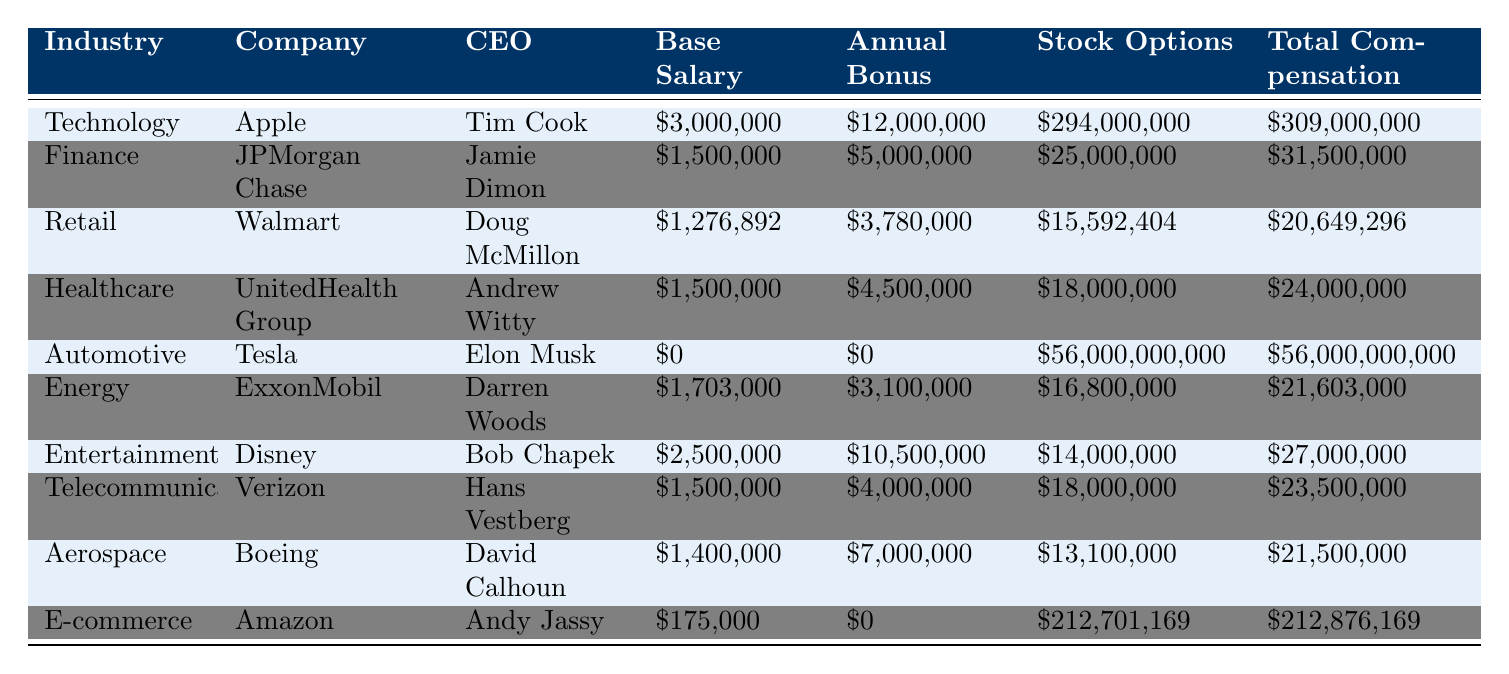What is the total compensation for Elon Musk? According to the table, the total compensation for Elon Musk, who is the CEO of Tesla, is listed as $56,000,000,000.
Answer: $56,000,000,000 Which CEO has the highest annual bonus? Reviewing the table, Tim Cook from Apple has the highest annual bonus of $12,000,000.
Answer: Tim Cook What is the average base salary of the CEOs listed in the table? The base salaries listed are $3,000,000 (Apple), $1,500,000 (JPMorgan Chase), $1,276,892 (Walmart), $1,500,000 (UnitedHealth Group), $0 (Tesla), $1,703,000 (ExxonMobil), $2,500,000 (Disney), $1,500,000 (Verizon), $1,400,000 (Boeing), and $175,000 (Amazon). Summing these gives $12,654,892. Dividing by the total count of CEOs (10) results in an average of $1,265,489.20.
Answer: $1,265,489.20 Is the total compensation for Amazon's CEO higher than that of JPMorgan Chase's CEO? The total compensation for Amazon's CEO, Andy Jassy, is $212,876,169, while for JPMorgan Chase's CEO, Jamie Dimon, it is $31,500,000. Comparing both values, $212,876,169 is greater than $31,500,000.
Answer: Yes What is the difference in total compensation between the highest and lowest paid CEOs? The highest total compensation is for Elon Musk at $56,000,000,000 and the lowest is for Andy Jassy at $212,876,169. Calculating the difference: $56,000,000,000 - $212,876,169 = $55,787,123,831.
Answer: $55,787,123,831 Which industry has the second highest total compensation? Looking at the total compensation values, Tesla has the highest ($56,000,000,000), followed by Apple at $309,000,000. Therefore, the second highest total compensation comes from Apple in the Technology industry.
Answer: Technology How much more in stock options does Tim Cook have compared to Doug McMillon? The stock options for Tim Cook are $294,000,000 and for Doug McMillon, they are $15,592,404. The difference is $294,000,000 - $15,592,404 = $278,407,596.
Answer: $278,407,596 Which industries show total compensations above $25,000,000? By examining the table, the industries with total compensations above $25,000,000 are Technology (Apple - $309,000,000), Automotive (Tesla - $56,000,000,000), Entertainment (Disney - $27,000,000), and E-commerce (Amazon - $212,876,169).
Answer: Technology, Automotive, Entertainment, E-commerce Who has a base salary of zero? The table shows that Elon Musk, the CEO of Tesla, has a base salary of $0.
Answer: Elon Musk What is the total annual bonus paid to CEOs in the Healthcare and Telecommunications industries combined? The annual bonuses for UnitedHealth Group (Healthcare) and Verizon (Telecommunications) are $4,500,000 and $4,000,000, respectively. The total annual bonus is calculated as $4,500,000 + $4,000,000 = $8,500,000.
Answer: $8,500,000 